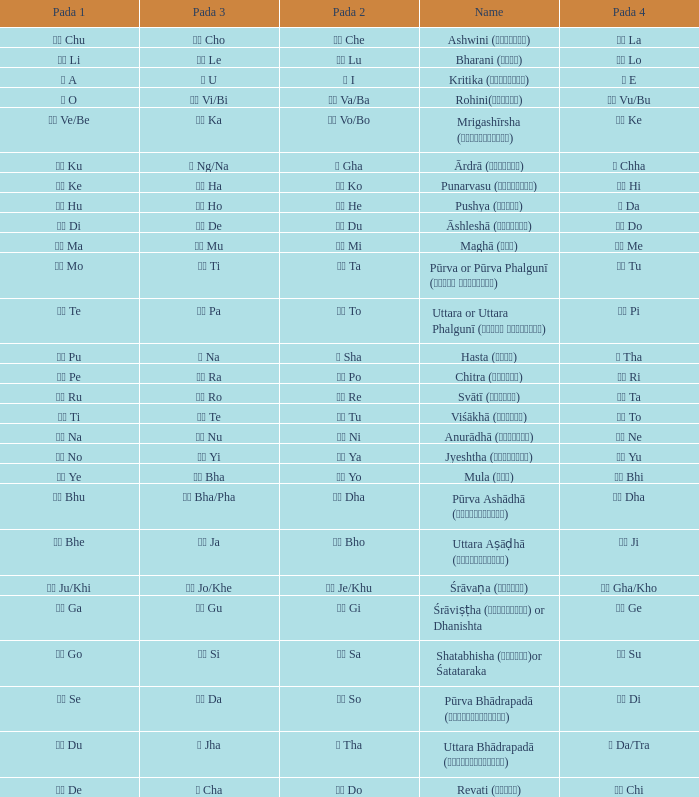Which pada 3 has a pada 2 of चे che? चो Cho. 